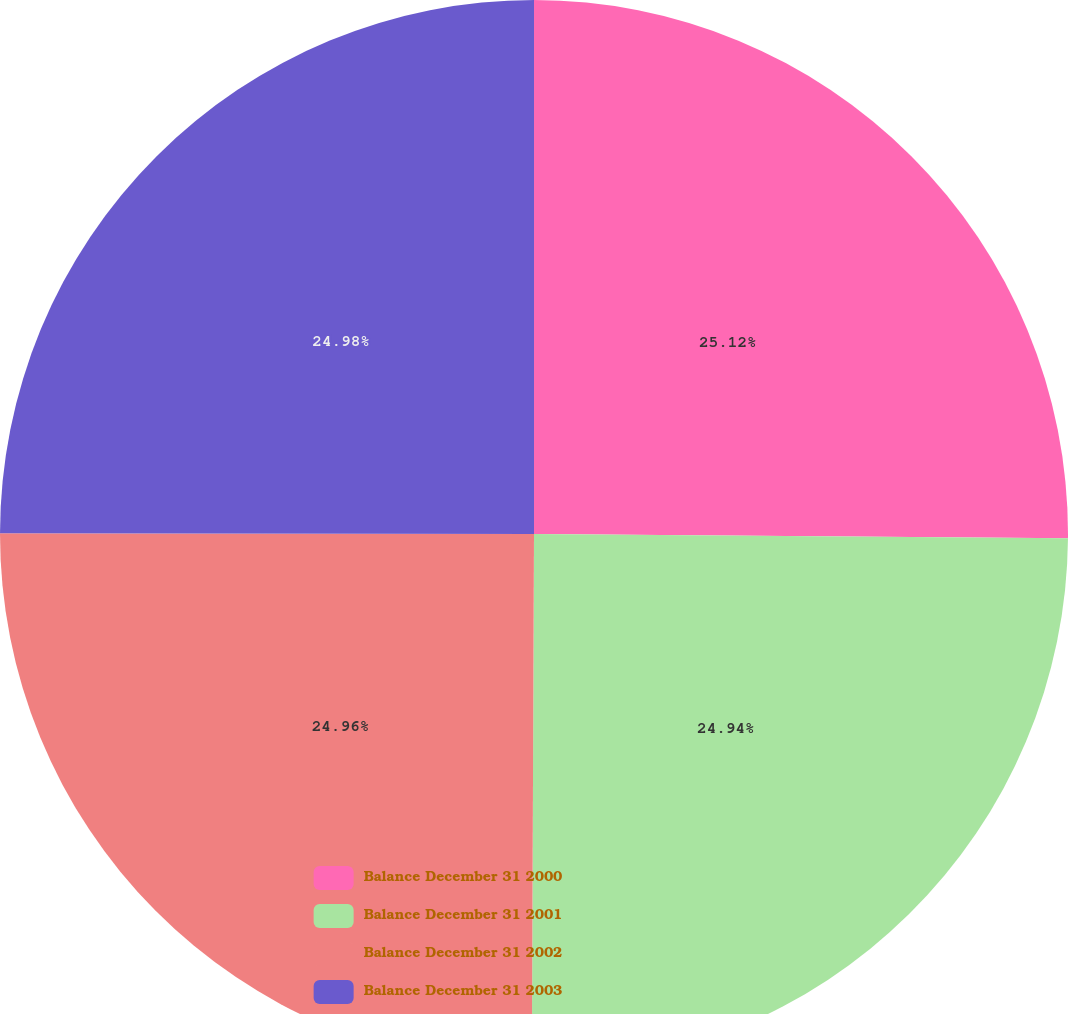<chart> <loc_0><loc_0><loc_500><loc_500><pie_chart><fcel>Balance December 31 2000<fcel>Balance December 31 2001<fcel>Balance December 31 2002<fcel>Balance December 31 2003<nl><fcel>25.13%<fcel>24.94%<fcel>24.96%<fcel>24.98%<nl></chart> 